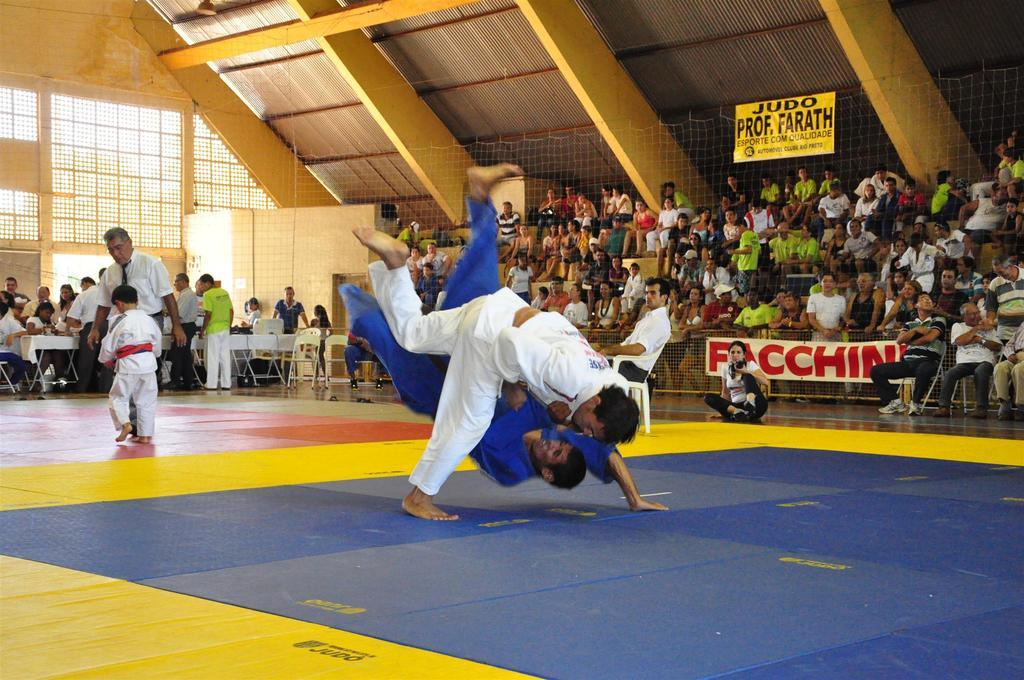What is happening in the center of the image? There are persons fighting in the center of the image. What objects are on the left side of the image? There are chairs and a table on the left side of the image. Are there any people on the left side of the image? Yes, there are persons on the left side of the image. What can be seen in the background of the image? There is a crowd in the background of the image. What type of relation does the person on the left have with the person in the center of the image? There is no information provided about the relationship between the persons in the image, so it cannot be determined. How many sisters are present in the image? There is no mention of any sisters in the image, so it cannot be determined. 